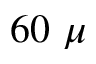Convert formula to latex. <formula><loc_0><loc_0><loc_500><loc_500>6 0 \ \mu</formula> 